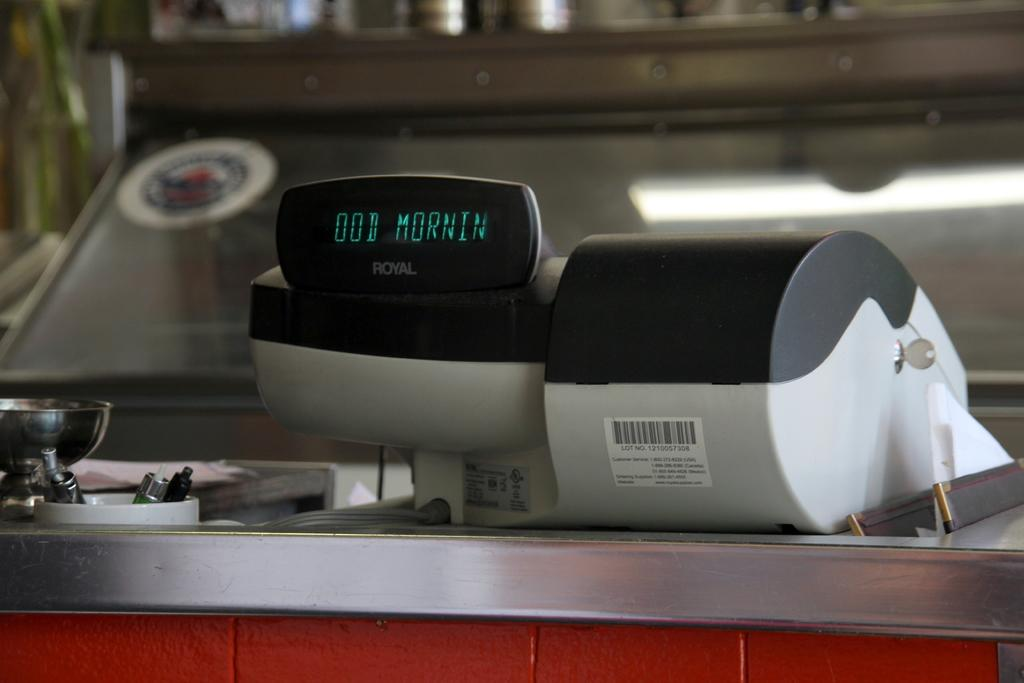<image>
Relay a brief, clear account of the picture shown. A Royal cash register says Good Morning on its readout. 